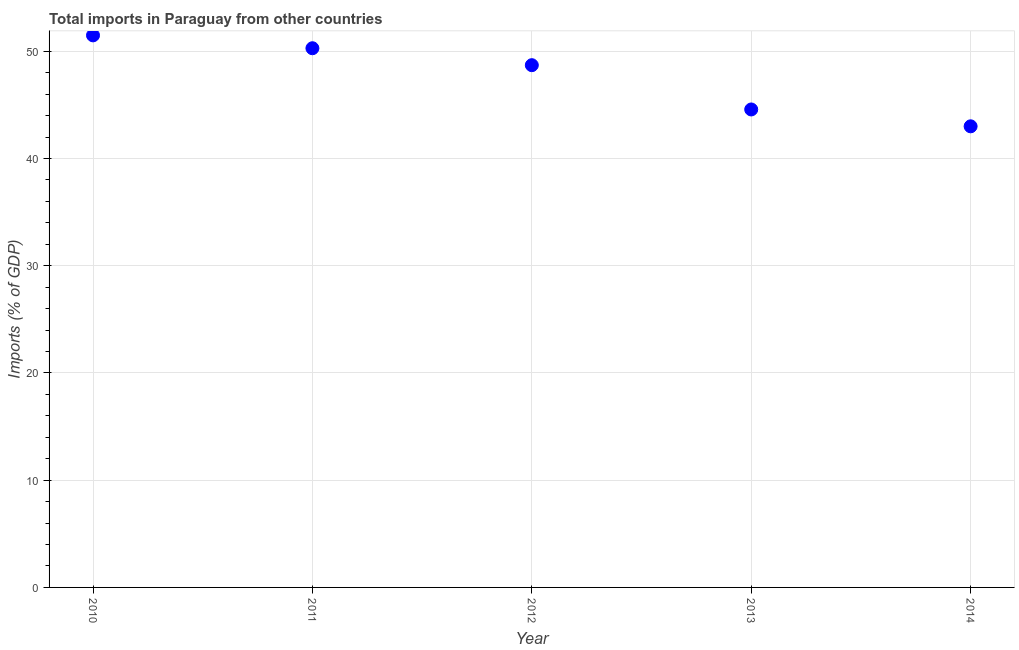What is the total imports in 2011?
Make the answer very short. 50.29. Across all years, what is the maximum total imports?
Your response must be concise. 51.49. Across all years, what is the minimum total imports?
Make the answer very short. 43. In which year was the total imports maximum?
Your response must be concise. 2010. What is the sum of the total imports?
Your answer should be compact. 238.06. What is the difference between the total imports in 2012 and 2014?
Offer a terse response. 5.7. What is the average total imports per year?
Ensure brevity in your answer.  47.61. What is the median total imports?
Give a very brief answer. 48.71. In how many years, is the total imports greater than 16 %?
Provide a succinct answer. 5. Do a majority of the years between 2013 and 2010 (inclusive) have total imports greater than 32 %?
Your answer should be compact. Yes. What is the ratio of the total imports in 2010 to that in 2012?
Make the answer very short. 1.06. What is the difference between the highest and the second highest total imports?
Your answer should be compact. 1.2. Is the sum of the total imports in 2011 and 2013 greater than the maximum total imports across all years?
Your response must be concise. Yes. What is the difference between the highest and the lowest total imports?
Provide a short and direct response. 8.48. In how many years, is the total imports greater than the average total imports taken over all years?
Offer a very short reply. 3. How many years are there in the graph?
Keep it short and to the point. 5. What is the difference between two consecutive major ticks on the Y-axis?
Offer a terse response. 10. Are the values on the major ticks of Y-axis written in scientific E-notation?
Provide a succinct answer. No. Does the graph contain any zero values?
Your answer should be compact. No. What is the title of the graph?
Provide a short and direct response. Total imports in Paraguay from other countries. What is the label or title of the X-axis?
Ensure brevity in your answer.  Year. What is the label or title of the Y-axis?
Give a very brief answer. Imports (% of GDP). What is the Imports (% of GDP) in 2010?
Provide a short and direct response. 51.49. What is the Imports (% of GDP) in 2011?
Give a very brief answer. 50.29. What is the Imports (% of GDP) in 2012?
Provide a succinct answer. 48.71. What is the Imports (% of GDP) in 2013?
Provide a short and direct response. 44.58. What is the Imports (% of GDP) in 2014?
Keep it short and to the point. 43. What is the difference between the Imports (% of GDP) in 2010 and 2011?
Give a very brief answer. 1.2. What is the difference between the Imports (% of GDP) in 2010 and 2012?
Your answer should be compact. 2.78. What is the difference between the Imports (% of GDP) in 2010 and 2013?
Give a very brief answer. 6.91. What is the difference between the Imports (% of GDP) in 2010 and 2014?
Make the answer very short. 8.48. What is the difference between the Imports (% of GDP) in 2011 and 2012?
Ensure brevity in your answer.  1.58. What is the difference between the Imports (% of GDP) in 2011 and 2013?
Your answer should be very brief. 5.71. What is the difference between the Imports (% of GDP) in 2011 and 2014?
Make the answer very short. 7.28. What is the difference between the Imports (% of GDP) in 2012 and 2013?
Your answer should be compact. 4.13. What is the difference between the Imports (% of GDP) in 2012 and 2014?
Your answer should be compact. 5.7. What is the difference between the Imports (% of GDP) in 2013 and 2014?
Your response must be concise. 1.57. What is the ratio of the Imports (% of GDP) in 2010 to that in 2012?
Offer a terse response. 1.06. What is the ratio of the Imports (% of GDP) in 2010 to that in 2013?
Give a very brief answer. 1.16. What is the ratio of the Imports (% of GDP) in 2010 to that in 2014?
Your response must be concise. 1.2. What is the ratio of the Imports (% of GDP) in 2011 to that in 2012?
Your response must be concise. 1.03. What is the ratio of the Imports (% of GDP) in 2011 to that in 2013?
Your response must be concise. 1.13. What is the ratio of the Imports (% of GDP) in 2011 to that in 2014?
Give a very brief answer. 1.17. What is the ratio of the Imports (% of GDP) in 2012 to that in 2013?
Your response must be concise. 1.09. What is the ratio of the Imports (% of GDP) in 2012 to that in 2014?
Ensure brevity in your answer.  1.13. 